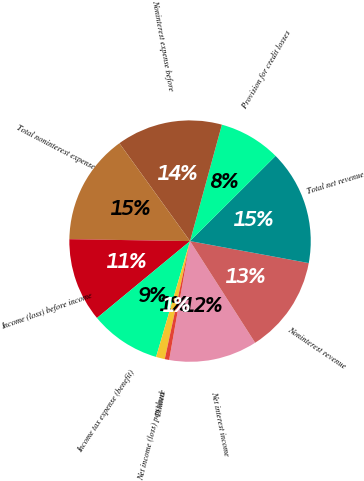Convert chart. <chart><loc_0><loc_0><loc_500><loc_500><pie_chart><fcel>Net interest income<fcel>Noninterest revenue<fcel>Total net revenue<fcel>Provision for credit losses<fcel>Noninterest expense before<fcel>Total noninterest expense<fcel>Income (loss) before income<fcel>Income tax expense (benefit)<fcel>Net income (loss) per share<fcel>Diluted<nl><fcel>11.83%<fcel>13.02%<fcel>15.38%<fcel>8.28%<fcel>14.2%<fcel>14.79%<fcel>11.24%<fcel>9.47%<fcel>1.18%<fcel>0.59%<nl></chart> 